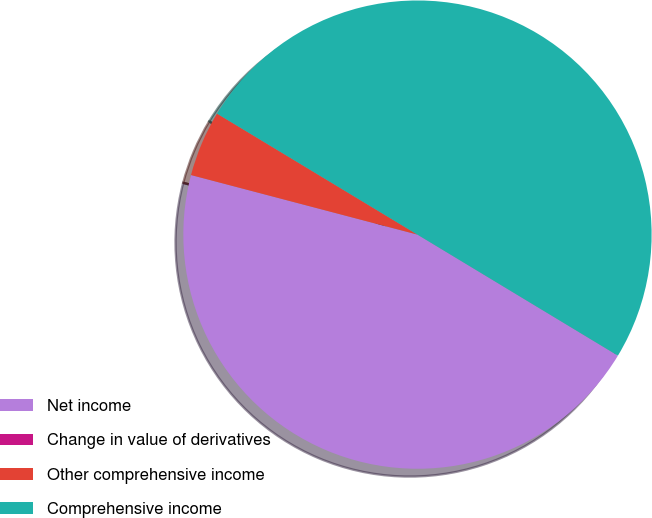<chart> <loc_0><loc_0><loc_500><loc_500><pie_chart><fcel>Net income<fcel>Change in value of derivatives<fcel>Other comprehensive income<fcel>Comprehensive income<nl><fcel>45.45%<fcel>0.0%<fcel>4.55%<fcel>50.0%<nl></chart> 